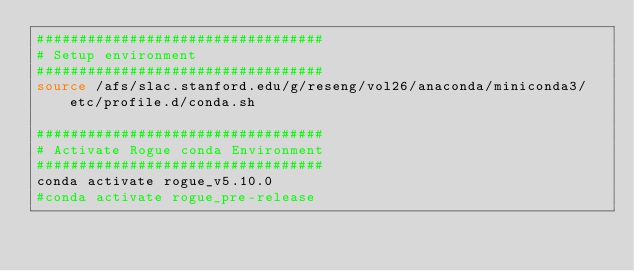<code> <loc_0><loc_0><loc_500><loc_500><_Bash_>##################################
# Setup environment
##################################
source /afs/slac.stanford.edu/g/reseng/vol26/anaconda/miniconda3/etc/profile.d/conda.sh

##################################
# Activate Rogue conda Environment
##################################
conda activate rogue_v5.10.0
#conda activate rogue_pre-release
</code> 